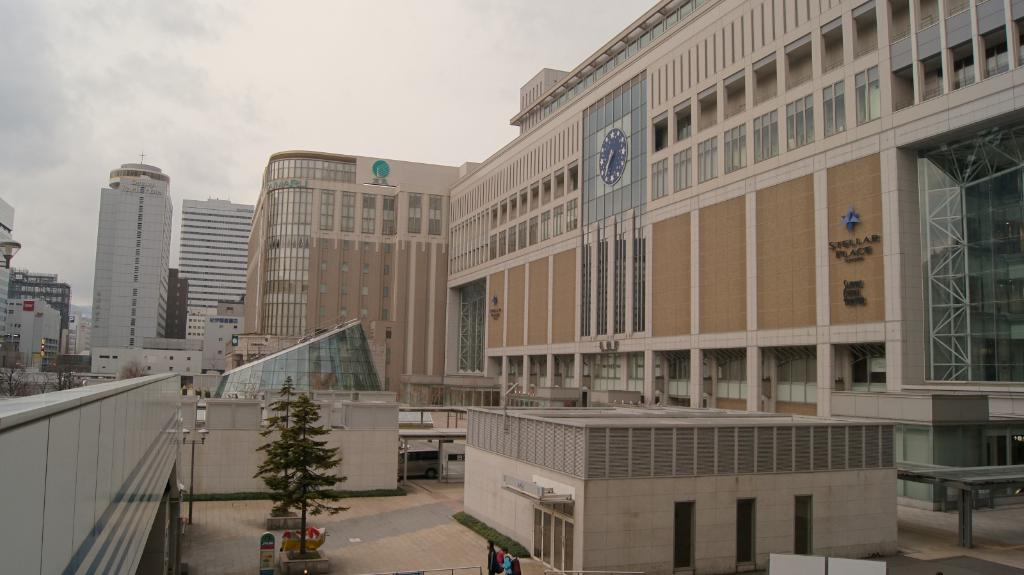What type of structures can be seen in the image? There are buildings in the image. Who or what else is present in the image? There are people and trees in the image. Can you describe any other elements in the image? There are objects in the image. What can be seen in the background of the image? The sky is visible in the background of the image. What type of watch is the creator wearing in the image? There is no watch or creator present in the image. What is the creator using to make the pot in the image? There is no pot or creator present in the image. 